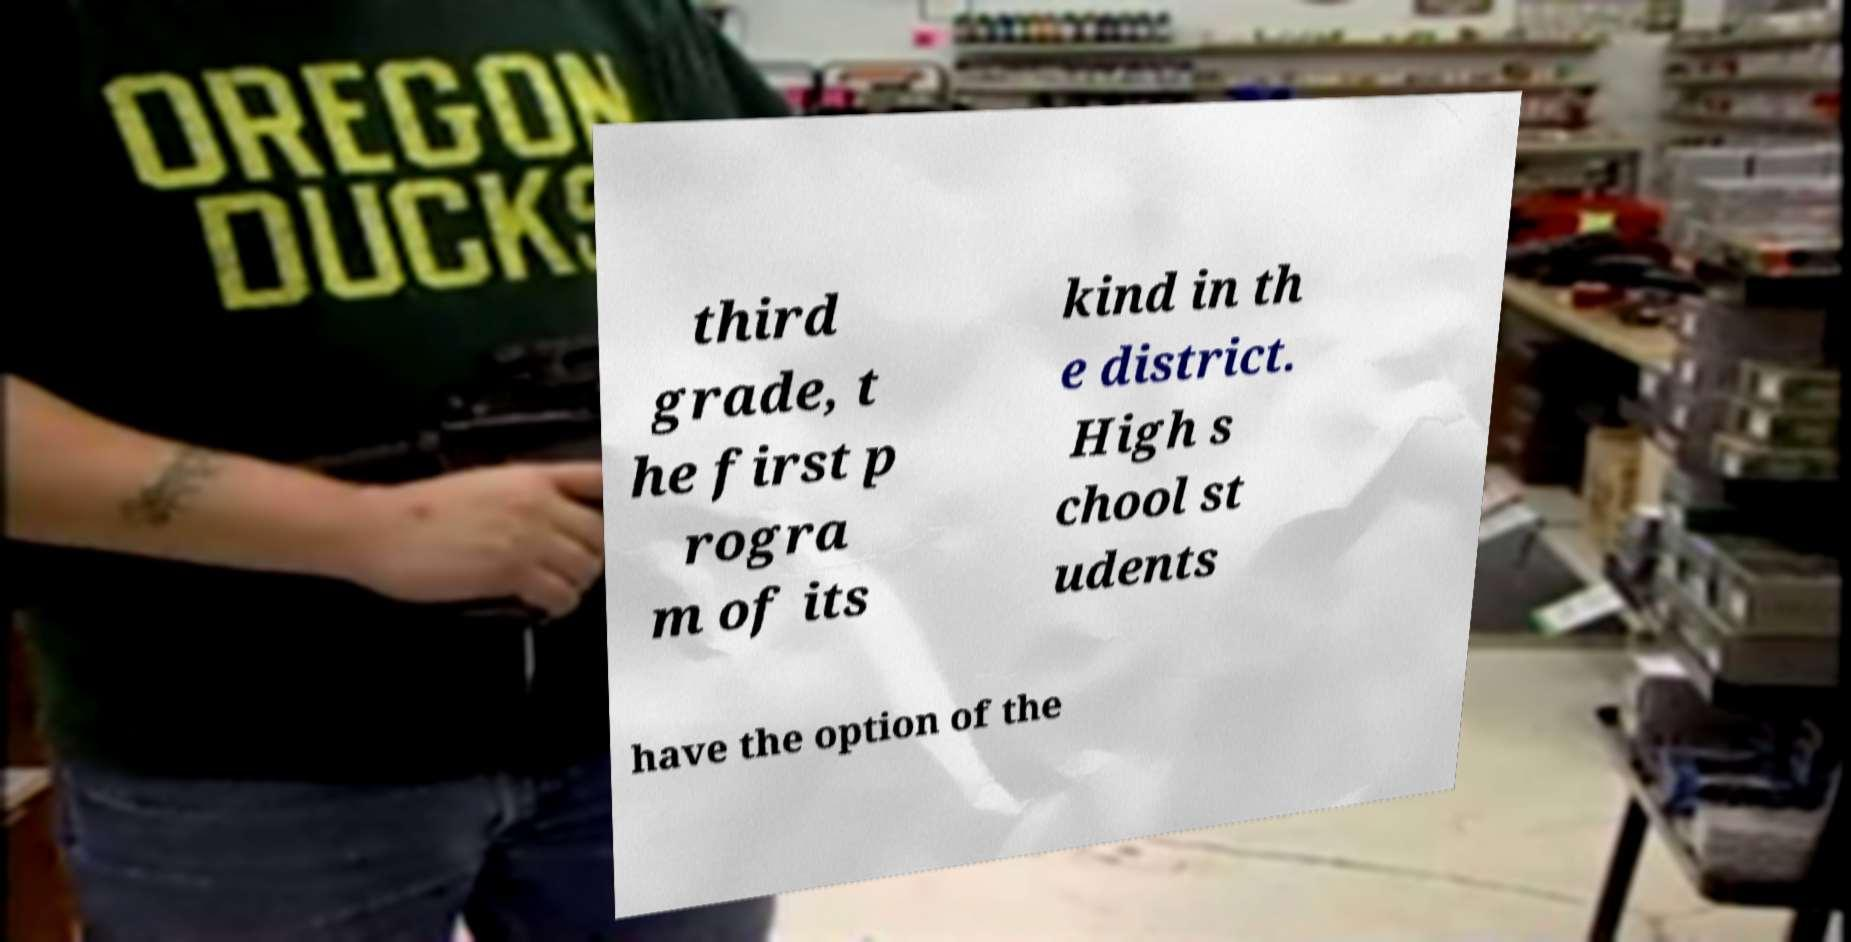Please read and relay the text visible in this image. What does it say? third grade, t he first p rogra m of its kind in th e district. High s chool st udents have the option of the 